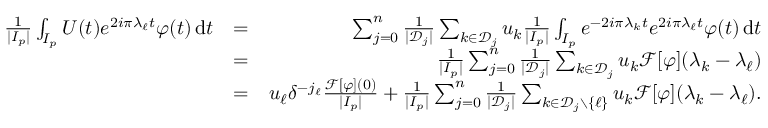Convert formula to latex. <formula><loc_0><loc_0><loc_500><loc_500>\begin{array} { r l r } { \frac { 1 } { | I _ { p } | } \int _ { I _ { p } } U ( t ) e ^ { 2 i \pi \lambda _ { \ell } t } \varphi ( t ) \, d t } & { = } & { \sum _ { j = 0 } ^ { n } \frac { 1 } { | { \mathcal { D } } _ { j } | } \sum _ { k \in { \mathcal { D } } _ { j } } u _ { k } \frac { 1 } { | I _ { p } | } \int _ { I _ { p } } e ^ { - 2 i \pi \lambda _ { k } t } e ^ { 2 i \pi \lambda _ { \ell } t } \varphi ( t ) \, d t } \\ & { = } & { \frac { 1 } { | I _ { p } | } \sum _ { j = 0 } ^ { n } \frac { 1 } { | { \mathcal { D } } _ { j } | } \sum _ { k \in { \mathcal { D } } _ { j } } u _ { k } { \mathcal { F } } [ \varphi ] ( \lambda _ { k } - \lambda _ { \ell } ) } \\ & { = } & { u _ { \ell } \delta ^ { - j _ { \ell } } \frac { { \mathcal { F } } [ \varphi ] ( 0 ) } { | I _ { p } | } + \frac { 1 } { | I _ { p } | } \sum _ { j = 0 } ^ { n } \frac { 1 } { | { \mathcal { D } } _ { j } | } \sum _ { k \in { \mathcal { D } } _ { j } \ \{ \ell \} } u _ { k } { \mathcal { F } } [ \varphi ] ( \lambda _ { k } - \lambda _ { \ell } ) . } \end{array}</formula> 